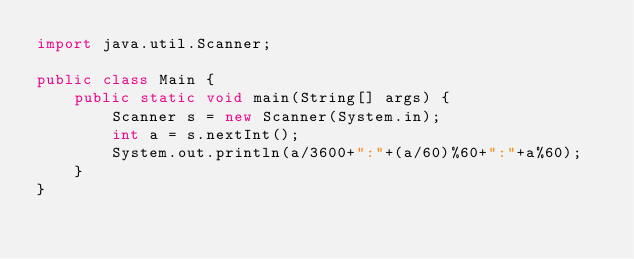<code> <loc_0><loc_0><loc_500><loc_500><_Java_>import java.util.Scanner;

public class Main {
    public static void main(String[] args) {
        Scanner s = new Scanner(System.in);
        int a = s.nextInt();
        System.out.println(a/3600+":"+(a/60)%60+":"+a%60);
    }
}</code> 